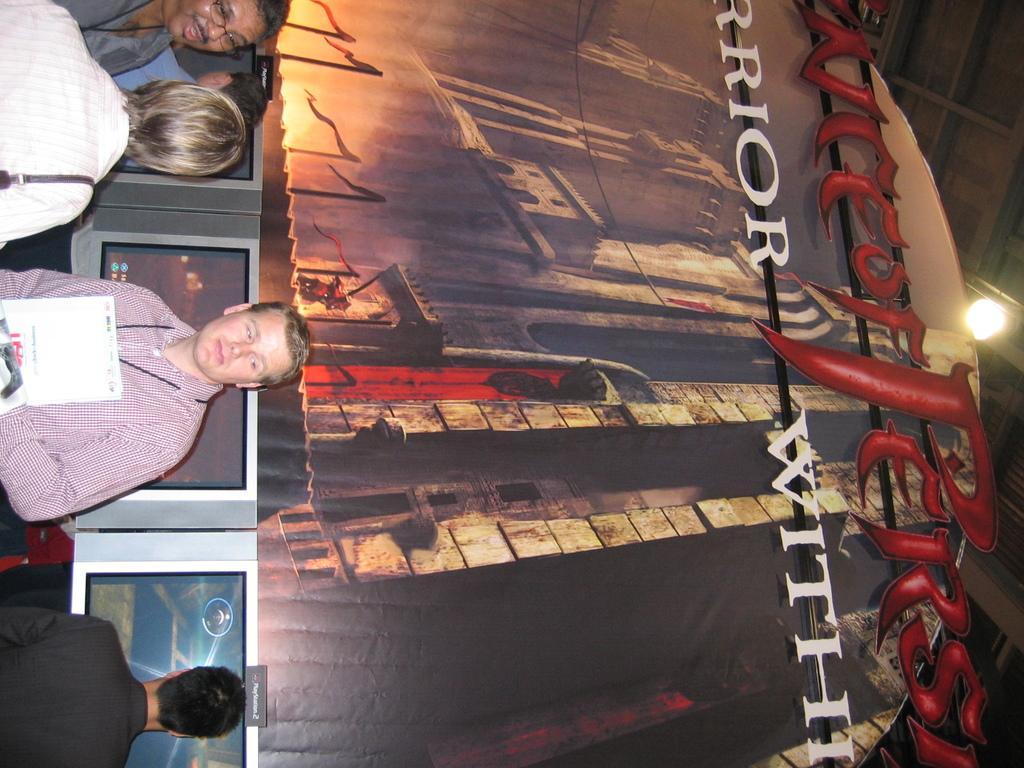Can you describe this image briefly? In this image I see few people and I see the screens and in the background I see the art over here and I see something is written and I see the light on the ceiling. 